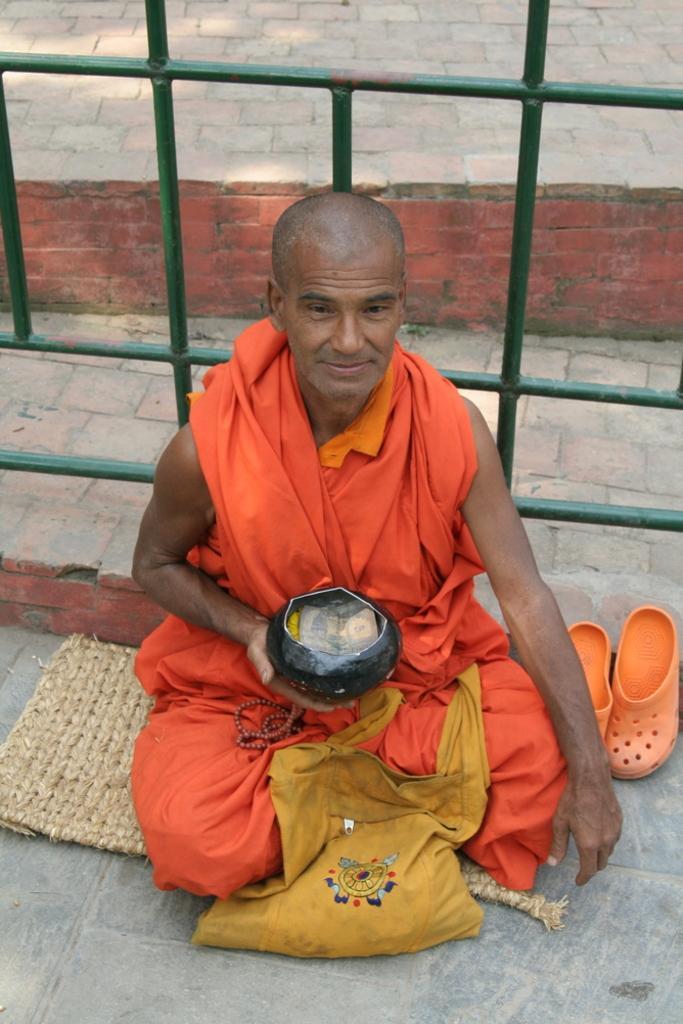Please provide a concise description of this image. In this picture there is a man who is wearing orange dress and holding a money box. Besides him I can see the shoes, bag and fencing. He is sitting on the mat. 